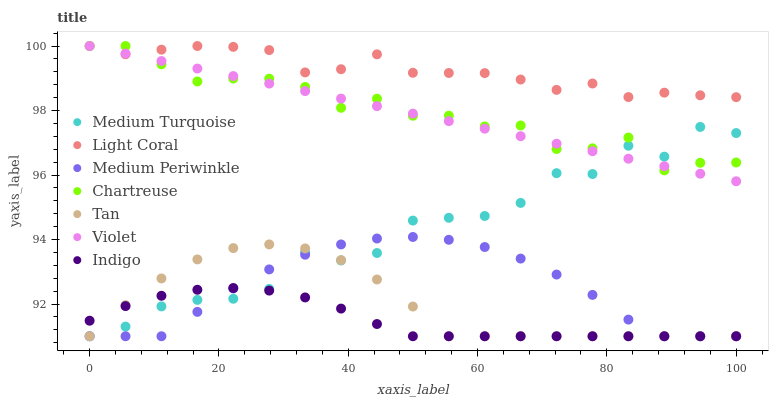Does Indigo have the minimum area under the curve?
Answer yes or no. Yes. Does Light Coral have the maximum area under the curve?
Answer yes or no. Yes. Does Medium Periwinkle have the minimum area under the curve?
Answer yes or no. No. Does Medium Periwinkle have the maximum area under the curve?
Answer yes or no. No. Is Violet the smoothest?
Answer yes or no. Yes. Is Medium Turquoise the roughest?
Answer yes or no. Yes. Is Medium Periwinkle the smoothest?
Answer yes or no. No. Is Medium Periwinkle the roughest?
Answer yes or no. No. Does Indigo have the lowest value?
Answer yes or no. Yes. Does Light Coral have the lowest value?
Answer yes or no. No. Does Violet have the highest value?
Answer yes or no. Yes. Does Medium Periwinkle have the highest value?
Answer yes or no. No. Is Medium Periwinkle less than Light Coral?
Answer yes or no. Yes. Is Light Coral greater than Medium Turquoise?
Answer yes or no. Yes. Does Medium Turquoise intersect Chartreuse?
Answer yes or no. Yes. Is Medium Turquoise less than Chartreuse?
Answer yes or no. No. Is Medium Turquoise greater than Chartreuse?
Answer yes or no. No. Does Medium Periwinkle intersect Light Coral?
Answer yes or no. No. 